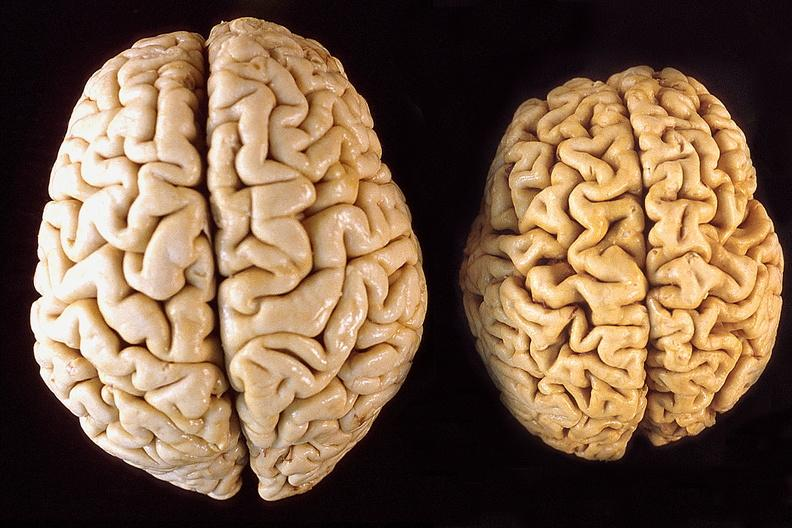does this image show brain, atrophy compared to normal?
Answer the question using a single word or phrase. Yes 